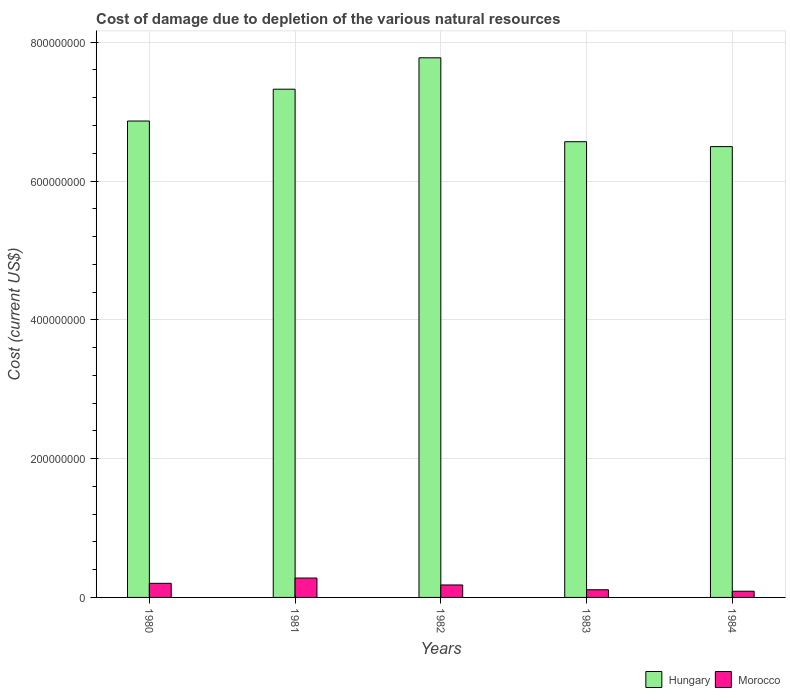How many different coloured bars are there?
Provide a succinct answer. 2. Are the number of bars per tick equal to the number of legend labels?
Keep it short and to the point. Yes. Are the number of bars on each tick of the X-axis equal?
Your response must be concise. Yes. How many bars are there on the 1st tick from the left?
Make the answer very short. 2. What is the label of the 4th group of bars from the left?
Offer a terse response. 1983. In how many cases, is the number of bars for a given year not equal to the number of legend labels?
Make the answer very short. 0. What is the cost of damage caused due to the depletion of various natural resources in Morocco in 1982?
Provide a succinct answer. 1.80e+07. Across all years, what is the maximum cost of damage caused due to the depletion of various natural resources in Hungary?
Give a very brief answer. 7.78e+08. Across all years, what is the minimum cost of damage caused due to the depletion of various natural resources in Morocco?
Your response must be concise. 8.93e+06. What is the total cost of damage caused due to the depletion of various natural resources in Morocco in the graph?
Offer a very short reply. 8.62e+07. What is the difference between the cost of damage caused due to the depletion of various natural resources in Morocco in 1980 and that in 1983?
Offer a terse response. 9.26e+06. What is the difference between the cost of damage caused due to the depletion of various natural resources in Morocco in 1982 and the cost of damage caused due to the depletion of various natural resources in Hungary in 1984?
Provide a succinct answer. -6.32e+08. What is the average cost of damage caused due to the depletion of various natural resources in Morocco per year?
Ensure brevity in your answer.  1.72e+07. In the year 1984, what is the difference between the cost of damage caused due to the depletion of various natural resources in Hungary and cost of damage caused due to the depletion of various natural resources in Morocco?
Your response must be concise. 6.41e+08. In how many years, is the cost of damage caused due to the depletion of various natural resources in Hungary greater than 600000000 US$?
Make the answer very short. 5. What is the ratio of the cost of damage caused due to the depletion of various natural resources in Hungary in 1982 to that in 1983?
Your answer should be compact. 1.18. Is the cost of damage caused due to the depletion of various natural resources in Morocco in 1981 less than that in 1982?
Provide a succinct answer. No. Is the difference between the cost of damage caused due to the depletion of various natural resources in Hungary in 1982 and 1983 greater than the difference between the cost of damage caused due to the depletion of various natural resources in Morocco in 1982 and 1983?
Offer a terse response. Yes. What is the difference between the highest and the second highest cost of damage caused due to the depletion of various natural resources in Morocco?
Your answer should be compact. 7.60e+06. What is the difference between the highest and the lowest cost of damage caused due to the depletion of various natural resources in Hungary?
Keep it short and to the point. 1.28e+08. In how many years, is the cost of damage caused due to the depletion of various natural resources in Morocco greater than the average cost of damage caused due to the depletion of various natural resources in Morocco taken over all years?
Make the answer very short. 3. Is the sum of the cost of damage caused due to the depletion of various natural resources in Hungary in 1981 and 1983 greater than the maximum cost of damage caused due to the depletion of various natural resources in Morocco across all years?
Offer a terse response. Yes. What does the 2nd bar from the left in 1982 represents?
Make the answer very short. Morocco. What does the 1st bar from the right in 1984 represents?
Your answer should be very brief. Morocco. How many years are there in the graph?
Provide a short and direct response. 5. What is the difference between two consecutive major ticks on the Y-axis?
Make the answer very short. 2.00e+08. Are the values on the major ticks of Y-axis written in scientific E-notation?
Your answer should be compact. No. Does the graph contain any zero values?
Your response must be concise. No. Where does the legend appear in the graph?
Offer a terse response. Bottom right. How many legend labels are there?
Your answer should be very brief. 2. How are the legend labels stacked?
Offer a terse response. Horizontal. What is the title of the graph?
Provide a short and direct response. Cost of damage due to depletion of the various natural resources. Does "Arab World" appear as one of the legend labels in the graph?
Give a very brief answer. No. What is the label or title of the X-axis?
Provide a short and direct response. Years. What is the label or title of the Y-axis?
Keep it short and to the point. Cost (current US$). What is the Cost (current US$) in Hungary in 1980?
Your answer should be compact. 6.86e+08. What is the Cost (current US$) of Morocco in 1980?
Make the answer very short. 2.03e+07. What is the Cost (current US$) of Hungary in 1981?
Offer a terse response. 7.32e+08. What is the Cost (current US$) in Morocco in 1981?
Give a very brief answer. 2.79e+07. What is the Cost (current US$) in Hungary in 1982?
Make the answer very short. 7.78e+08. What is the Cost (current US$) of Morocco in 1982?
Make the answer very short. 1.80e+07. What is the Cost (current US$) in Hungary in 1983?
Your response must be concise. 6.57e+08. What is the Cost (current US$) of Morocco in 1983?
Offer a terse response. 1.11e+07. What is the Cost (current US$) in Hungary in 1984?
Make the answer very short. 6.50e+08. What is the Cost (current US$) in Morocco in 1984?
Your answer should be very brief. 8.93e+06. Across all years, what is the maximum Cost (current US$) in Hungary?
Give a very brief answer. 7.78e+08. Across all years, what is the maximum Cost (current US$) of Morocco?
Make the answer very short. 2.79e+07. Across all years, what is the minimum Cost (current US$) in Hungary?
Offer a terse response. 6.50e+08. Across all years, what is the minimum Cost (current US$) of Morocco?
Offer a terse response. 8.93e+06. What is the total Cost (current US$) in Hungary in the graph?
Make the answer very short. 3.50e+09. What is the total Cost (current US$) of Morocco in the graph?
Keep it short and to the point. 8.62e+07. What is the difference between the Cost (current US$) in Hungary in 1980 and that in 1981?
Ensure brevity in your answer.  -4.59e+07. What is the difference between the Cost (current US$) of Morocco in 1980 and that in 1981?
Your answer should be very brief. -7.60e+06. What is the difference between the Cost (current US$) of Hungary in 1980 and that in 1982?
Ensure brevity in your answer.  -9.11e+07. What is the difference between the Cost (current US$) in Morocco in 1980 and that in 1982?
Offer a very short reply. 2.36e+06. What is the difference between the Cost (current US$) in Hungary in 1980 and that in 1983?
Ensure brevity in your answer.  2.98e+07. What is the difference between the Cost (current US$) of Morocco in 1980 and that in 1983?
Offer a terse response. 9.26e+06. What is the difference between the Cost (current US$) in Hungary in 1980 and that in 1984?
Make the answer very short. 3.69e+07. What is the difference between the Cost (current US$) in Morocco in 1980 and that in 1984?
Keep it short and to the point. 1.14e+07. What is the difference between the Cost (current US$) of Hungary in 1981 and that in 1982?
Make the answer very short. -4.52e+07. What is the difference between the Cost (current US$) of Morocco in 1981 and that in 1982?
Offer a terse response. 9.96e+06. What is the difference between the Cost (current US$) of Hungary in 1981 and that in 1983?
Your response must be concise. 7.57e+07. What is the difference between the Cost (current US$) of Morocco in 1981 and that in 1983?
Provide a short and direct response. 1.69e+07. What is the difference between the Cost (current US$) of Hungary in 1981 and that in 1984?
Your answer should be compact. 8.27e+07. What is the difference between the Cost (current US$) in Morocco in 1981 and that in 1984?
Ensure brevity in your answer.  1.90e+07. What is the difference between the Cost (current US$) of Hungary in 1982 and that in 1983?
Provide a short and direct response. 1.21e+08. What is the difference between the Cost (current US$) of Morocco in 1982 and that in 1983?
Provide a succinct answer. 6.90e+06. What is the difference between the Cost (current US$) of Hungary in 1982 and that in 1984?
Your response must be concise. 1.28e+08. What is the difference between the Cost (current US$) in Morocco in 1982 and that in 1984?
Provide a succinct answer. 9.04e+06. What is the difference between the Cost (current US$) in Hungary in 1983 and that in 1984?
Make the answer very short. 7.03e+06. What is the difference between the Cost (current US$) in Morocco in 1983 and that in 1984?
Provide a succinct answer. 2.14e+06. What is the difference between the Cost (current US$) of Hungary in 1980 and the Cost (current US$) of Morocco in 1981?
Keep it short and to the point. 6.59e+08. What is the difference between the Cost (current US$) in Hungary in 1980 and the Cost (current US$) in Morocco in 1982?
Your response must be concise. 6.68e+08. What is the difference between the Cost (current US$) of Hungary in 1980 and the Cost (current US$) of Morocco in 1983?
Give a very brief answer. 6.75e+08. What is the difference between the Cost (current US$) in Hungary in 1980 and the Cost (current US$) in Morocco in 1984?
Provide a short and direct response. 6.78e+08. What is the difference between the Cost (current US$) in Hungary in 1981 and the Cost (current US$) in Morocco in 1982?
Offer a terse response. 7.14e+08. What is the difference between the Cost (current US$) in Hungary in 1981 and the Cost (current US$) in Morocco in 1983?
Keep it short and to the point. 7.21e+08. What is the difference between the Cost (current US$) in Hungary in 1981 and the Cost (current US$) in Morocco in 1984?
Your response must be concise. 7.23e+08. What is the difference between the Cost (current US$) of Hungary in 1982 and the Cost (current US$) of Morocco in 1983?
Provide a short and direct response. 7.66e+08. What is the difference between the Cost (current US$) of Hungary in 1982 and the Cost (current US$) of Morocco in 1984?
Make the answer very short. 7.69e+08. What is the difference between the Cost (current US$) of Hungary in 1983 and the Cost (current US$) of Morocco in 1984?
Provide a succinct answer. 6.48e+08. What is the average Cost (current US$) of Hungary per year?
Your response must be concise. 7.01e+08. What is the average Cost (current US$) of Morocco per year?
Offer a terse response. 1.72e+07. In the year 1980, what is the difference between the Cost (current US$) of Hungary and Cost (current US$) of Morocco?
Ensure brevity in your answer.  6.66e+08. In the year 1981, what is the difference between the Cost (current US$) in Hungary and Cost (current US$) in Morocco?
Your answer should be very brief. 7.04e+08. In the year 1982, what is the difference between the Cost (current US$) of Hungary and Cost (current US$) of Morocco?
Give a very brief answer. 7.60e+08. In the year 1983, what is the difference between the Cost (current US$) in Hungary and Cost (current US$) in Morocco?
Offer a terse response. 6.46e+08. In the year 1984, what is the difference between the Cost (current US$) of Hungary and Cost (current US$) of Morocco?
Make the answer very short. 6.41e+08. What is the ratio of the Cost (current US$) in Hungary in 1980 to that in 1981?
Make the answer very short. 0.94. What is the ratio of the Cost (current US$) of Morocco in 1980 to that in 1981?
Your answer should be compact. 0.73. What is the ratio of the Cost (current US$) in Hungary in 1980 to that in 1982?
Provide a succinct answer. 0.88. What is the ratio of the Cost (current US$) in Morocco in 1980 to that in 1982?
Keep it short and to the point. 1.13. What is the ratio of the Cost (current US$) in Hungary in 1980 to that in 1983?
Keep it short and to the point. 1.05. What is the ratio of the Cost (current US$) of Morocco in 1980 to that in 1983?
Ensure brevity in your answer.  1.84. What is the ratio of the Cost (current US$) in Hungary in 1980 to that in 1984?
Give a very brief answer. 1.06. What is the ratio of the Cost (current US$) in Morocco in 1980 to that in 1984?
Give a very brief answer. 2.28. What is the ratio of the Cost (current US$) of Hungary in 1981 to that in 1982?
Offer a terse response. 0.94. What is the ratio of the Cost (current US$) in Morocco in 1981 to that in 1982?
Keep it short and to the point. 1.55. What is the ratio of the Cost (current US$) of Hungary in 1981 to that in 1983?
Make the answer very short. 1.12. What is the ratio of the Cost (current US$) in Morocco in 1981 to that in 1983?
Offer a terse response. 2.52. What is the ratio of the Cost (current US$) in Hungary in 1981 to that in 1984?
Provide a succinct answer. 1.13. What is the ratio of the Cost (current US$) of Morocco in 1981 to that in 1984?
Keep it short and to the point. 3.13. What is the ratio of the Cost (current US$) in Hungary in 1982 to that in 1983?
Offer a very short reply. 1.18. What is the ratio of the Cost (current US$) in Morocco in 1982 to that in 1983?
Your answer should be compact. 1.62. What is the ratio of the Cost (current US$) of Hungary in 1982 to that in 1984?
Ensure brevity in your answer.  1.2. What is the ratio of the Cost (current US$) in Morocco in 1982 to that in 1984?
Your answer should be very brief. 2.01. What is the ratio of the Cost (current US$) in Hungary in 1983 to that in 1984?
Your answer should be very brief. 1.01. What is the ratio of the Cost (current US$) of Morocco in 1983 to that in 1984?
Provide a succinct answer. 1.24. What is the difference between the highest and the second highest Cost (current US$) in Hungary?
Make the answer very short. 4.52e+07. What is the difference between the highest and the second highest Cost (current US$) in Morocco?
Your answer should be compact. 7.60e+06. What is the difference between the highest and the lowest Cost (current US$) of Hungary?
Provide a succinct answer. 1.28e+08. What is the difference between the highest and the lowest Cost (current US$) in Morocco?
Offer a terse response. 1.90e+07. 